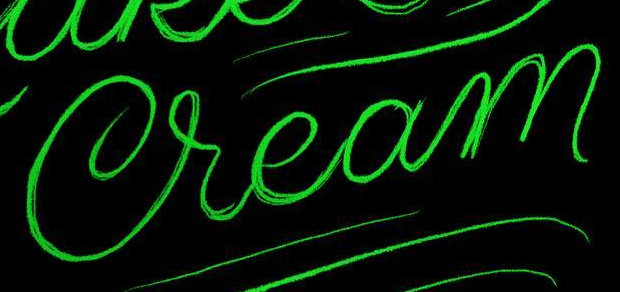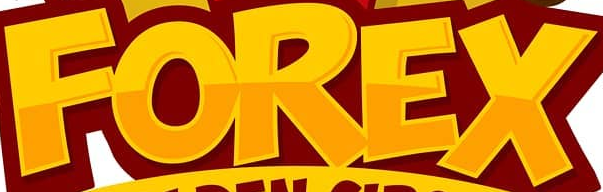What words are shown in these images in order, separated by a semicolon? Cream; FOREX 